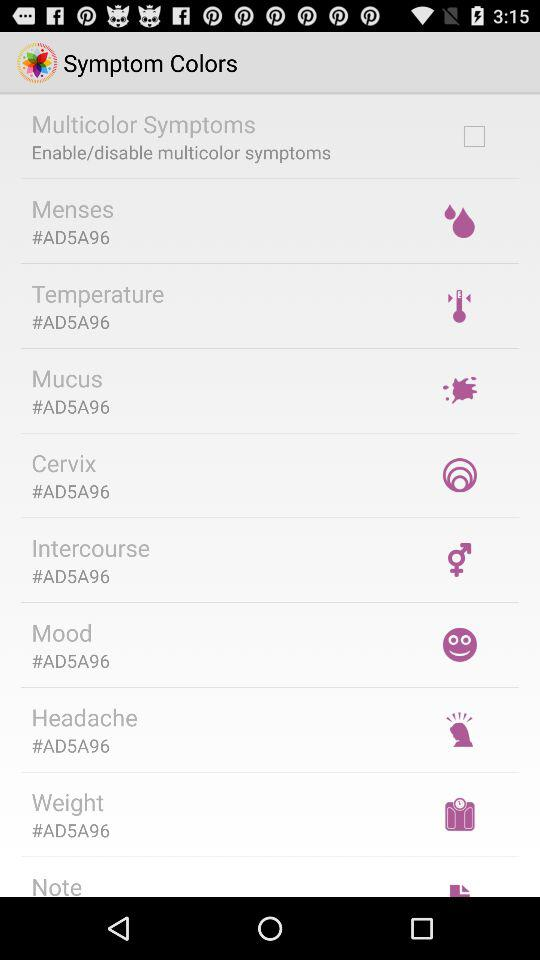What is the status of the "Multicolor Symptoms"? The status is "off". 